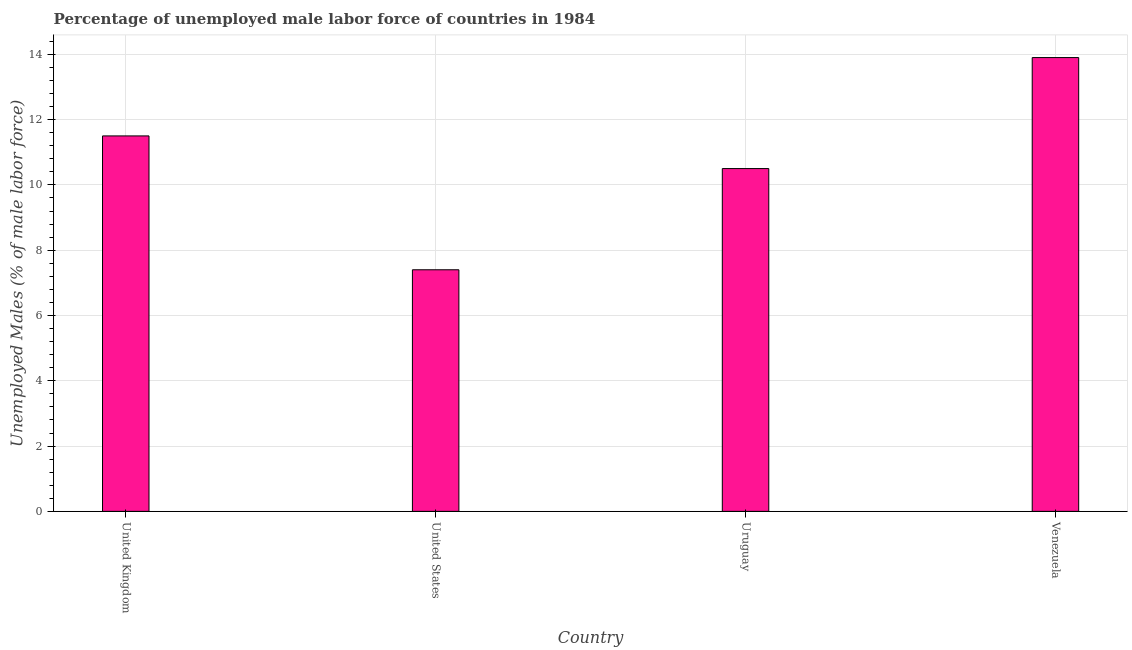Does the graph contain any zero values?
Ensure brevity in your answer.  No. What is the title of the graph?
Make the answer very short. Percentage of unemployed male labor force of countries in 1984. What is the label or title of the X-axis?
Provide a succinct answer. Country. What is the label or title of the Y-axis?
Provide a short and direct response. Unemployed Males (% of male labor force). What is the total unemployed male labour force in United States?
Offer a terse response. 7.4. Across all countries, what is the maximum total unemployed male labour force?
Give a very brief answer. 13.9. Across all countries, what is the minimum total unemployed male labour force?
Your answer should be compact. 7.4. In which country was the total unemployed male labour force maximum?
Provide a succinct answer. Venezuela. In which country was the total unemployed male labour force minimum?
Make the answer very short. United States. What is the sum of the total unemployed male labour force?
Your response must be concise. 43.3. What is the average total unemployed male labour force per country?
Offer a terse response. 10.82. In how many countries, is the total unemployed male labour force greater than 12.4 %?
Your response must be concise. 1. What is the ratio of the total unemployed male labour force in United Kingdom to that in Uruguay?
Your response must be concise. 1.09. Is the difference between the total unemployed male labour force in Uruguay and Venezuela greater than the difference between any two countries?
Ensure brevity in your answer.  No. What is the difference between the highest and the second highest total unemployed male labour force?
Keep it short and to the point. 2.4. How many countries are there in the graph?
Provide a succinct answer. 4. Are the values on the major ticks of Y-axis written in scientific E-notation?
Offer a very short reply. No. What is the Unemployed Males (% of male labor force) of United States?
Provide a succinct answer. 7.4. What is the Unemployed Males (% of male labor force) in Uruguay?
Make the answer very short. 10.5. What is the Unemployed Males (% of male labor force) in Venezuela?
Give a very brief answer. 13.9. What is the difference between the Unemployed Males (% of male labor force) in United States and Venezuela?
Your answer should be compact. -6.5. What is the difference between the Unemployed Males (% of male labor force) in Uruguay and Venezuela?
Make the answer very short. -3.4. What is the ratio of the Unemployed Males (% of male labor force) in United Kingdom to that in United States?
Give a very brief answer. 1.55. What is the ratio of the Unemployed Males (% of male labor force) in United Kingdom to that in Uruguay?
Provide a short and direct response. 1.09. What is the ratio of the Unemployed Males (% of male labor force) in United Kingdom to that in Venezuela?
Keep it short and to the point. 0.83. What is the ratio of the Unemployed Males (% of male labor force) in United States to that in Uruguay?
Offer a terse response. 0.7. What is the ratio of the Unemployed Males (% of male labor force) in United States to that in Venezuela?
Provide a short and direct response. 0.53. What is the ratio of the Unemployed Males (% of male labor force) in Uruguay to that in Venezuela?
Make the answer very short. 0.76. 